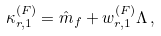Convert formula to latex. <formula><loc_0><loc_0><loc_500><loc_500>\kappa _ { r , 1 } ^ { ( F ) } = \hat { m } _ { f } + w _ { r , 1 } ^ { ( F ) } \Lambda \, ,</formula> 